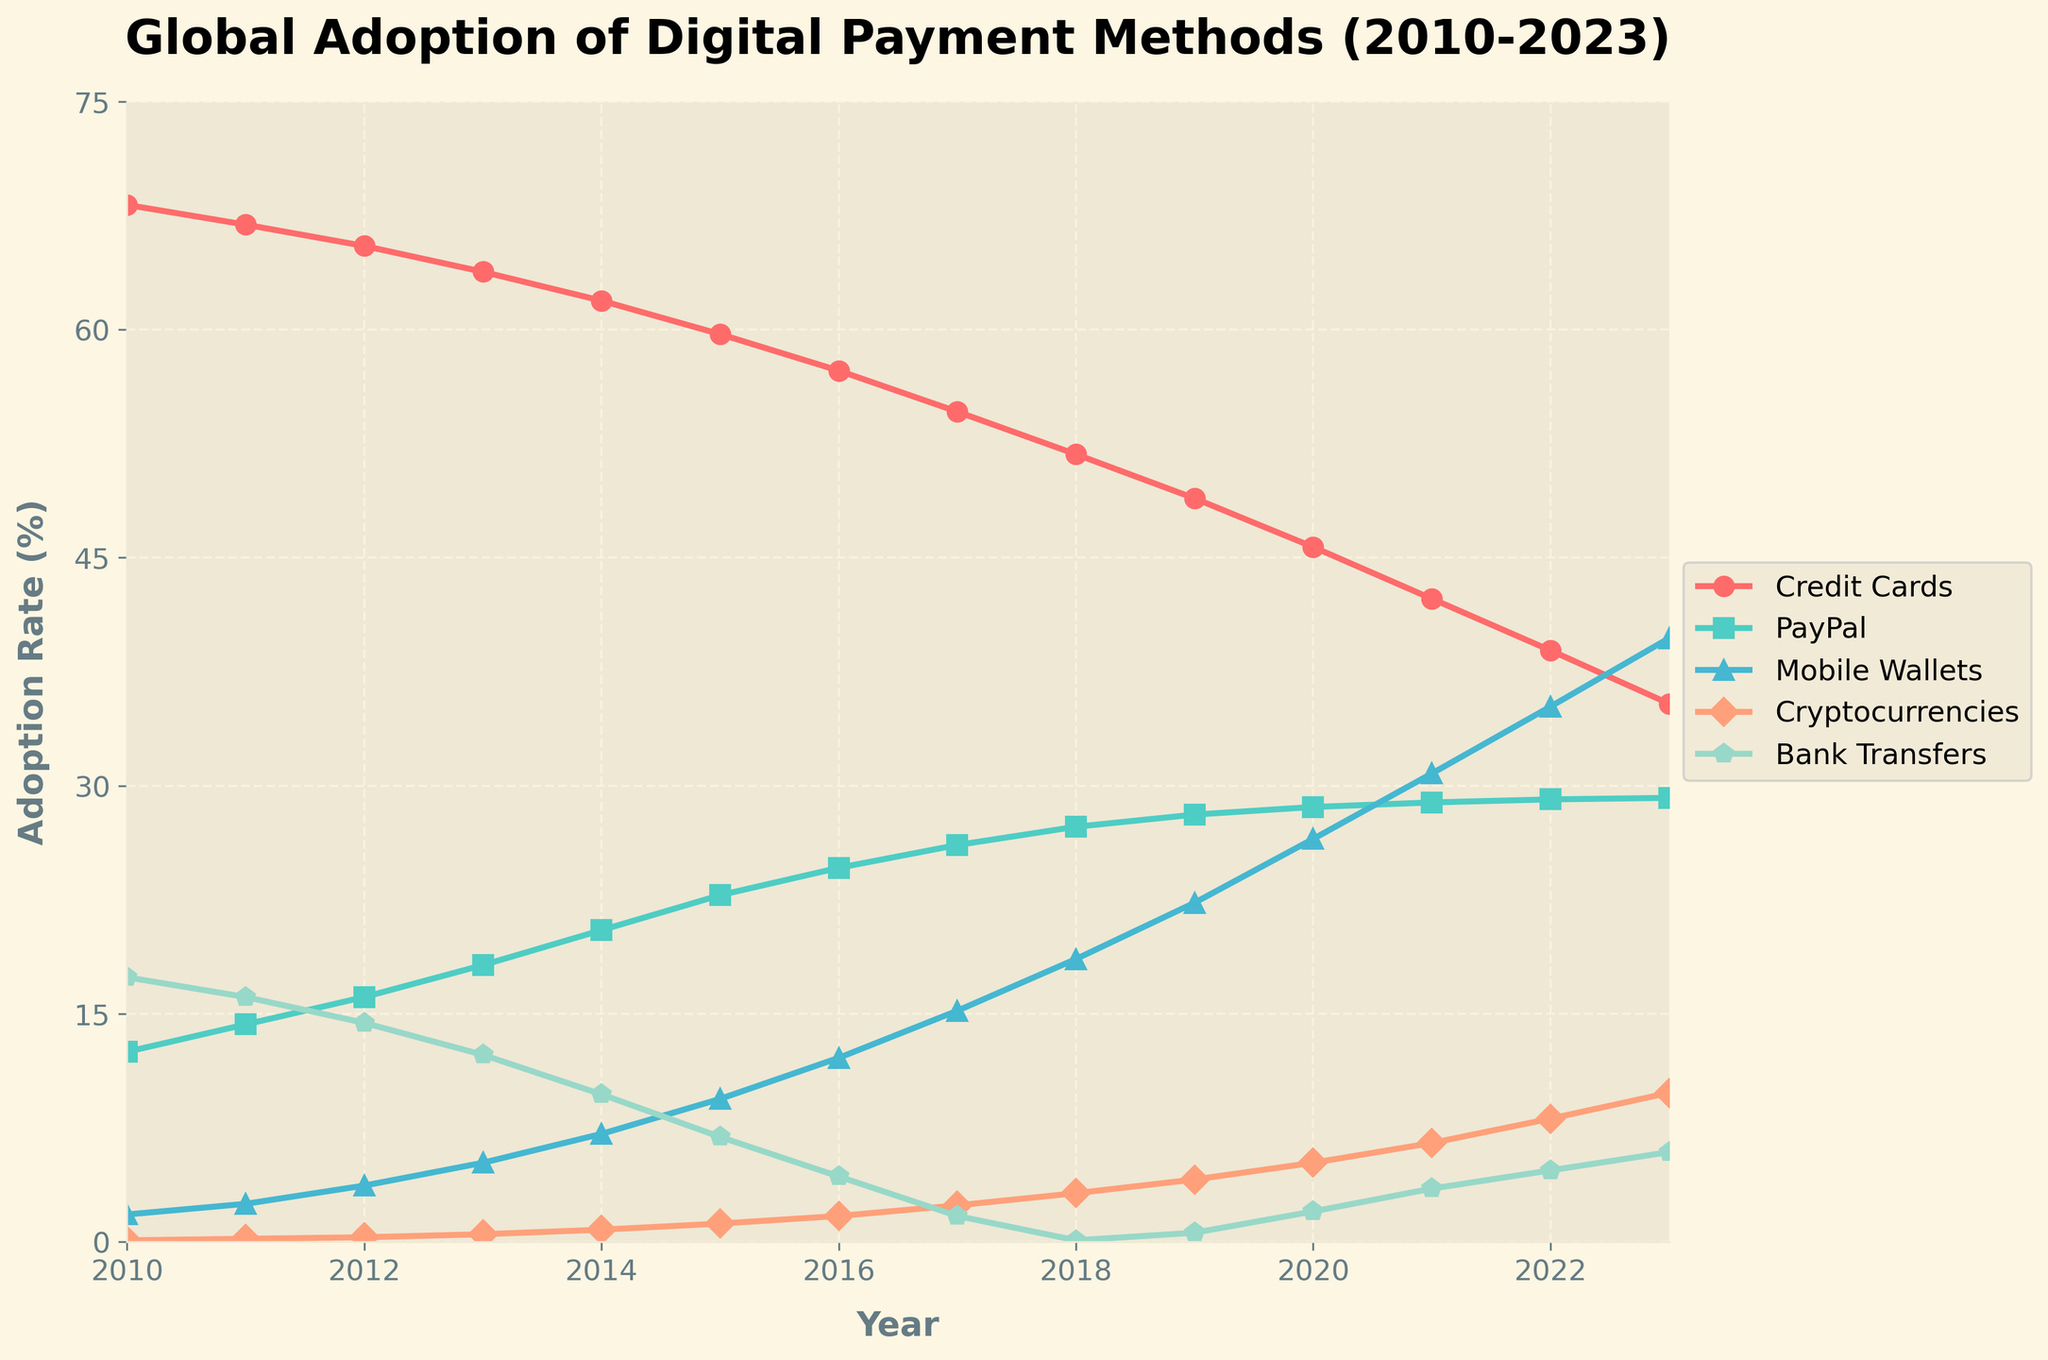What trend is observed in the adoption rate of Credit Cards from 2010 to 2023? The adoption rate of Credit Cards shows a consistent decline. It starts at 68.2% in 2010 and decreases to 35.4% in 2023.
Answer: Declining What year did Mobile Wallets adoption surpass PayPal adoption rate? Mobile Wallets surpassed PayPal in adoption rate in 2021 when Mobile Wallets had a 30.8% adoption rate, higher than PayPal’s 28.9%.
Answer: 2021 Between which consecutive years did Cryptocurrencies see the highest increase in adoption rate? The highest increase in adoption rate for Cryptocurrencies is observed between 2022 (8.1%) and 2023 (9.8%), with a difference of 1.7 percentage points.
Answer: 2022 and 2023 By how much did the adoption rate of Bank Transfers drop from 2010 to 2018? The adoption rate of Bank Transfers dropped from 17.4% in 2010 to 0.1% in 2018, a difference of 17.3 percentage points.
Answer: 17.3% Which payment method had the highest adoption rate in 2015, and what was it? In 2015, Credit Cards had the highest adoption rate at 59.7%.
Answer: Credit Cards, 59.7% What was the average adoption rate of PayPal between 2010 and 2023? To find the average, sum adoption rates for PayPal from 2010 to 2023 and divide by the number of years. (12.5 + 14.3 + 16.1 + 18.2 + 20.5 + 22.8 + 24.6 + 26.1 + 27.3 + 28.1 + 28.6 + 28.9 + 29.1 + 29.2) / 14 = 22.9%.
Answer: 22.9% Compare the adoption rates of Mobile Wallets and Cryptocurrencies in 2017. In 2017, Mobile Wallets had an adoption rate of 15.2%, while Cryptocurrencies had 2.4%. Mobile Wallets had a significantly higher adoption rate compared to Cryptocurrencies.
Answer: Mobile Wallets In which year does the difference between Mobile Wallets and PayPal adoption rate become greater than 10%? This occurs in 2023, where Mobile Wallets (39.7%) had an adoption rate that was 10.5% higher than PayPal (29.2%).
Answer: 2023 What adoption rate did Cryptocurrencies reach in 2020, and what visual representation (such as color) is used for Cryptocurrencies in the chart? In 2020, Cryptocurrencies reached an adoption rate of 5.2%. Cryptocurrencies are represented with a salmon color in the chart.
Answer: 5.2%, salmon 